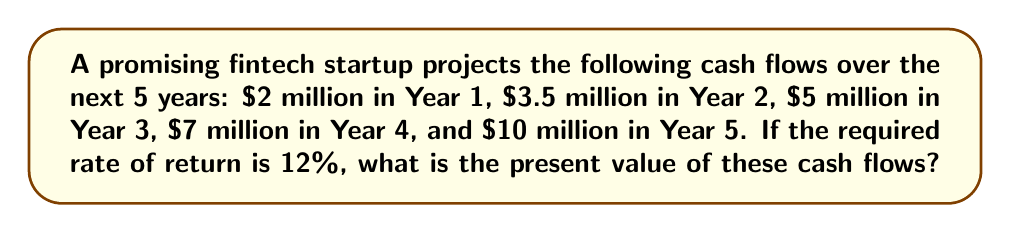Could you help me with this problem? To calculate the present value of future cash flows, we'll use the present value formula for each year and sum the results:

$$ PV = \sum_{t=1}^n \frac{CF_t}{(1+r)^t} $$

Where:
$PV$ = Present Value
$CF_t$ = Cash Flow in year t
$r$ = Required rate of return
$n$ = Number of years

Let's calculate the present value for each year:

Year 1: $PV_1 = \frac{2,000,000}{(1+0.12)^1} = 1,785,714.29$

Year 2: $PV_2 = \frac{3,500,000}{(1+0.12)^2} = 2,789,351.85$

Year 3: $PV_3 = \frac{5,000,000}{(1+0.12)^3} = 3,556,189.91$

Year 4: $PV_4 = \frac{7,000,000}{(1+0.12)^4} = 4,443,210.90$

Year 5: $PV_5 = \frac{10,000,000}{(1+0.12)^5} = 5,674,273.52$

Now, we sum all the present values:

$$ PV_{total} = 1,785,714.29 + 2,789,351.85 + 3,556,189.91 + 4,443,210.90 + 5,674,273.52 $$

$$ PV_{total} = 18,248,740.47 $$
Answer: $18,248,740.47 